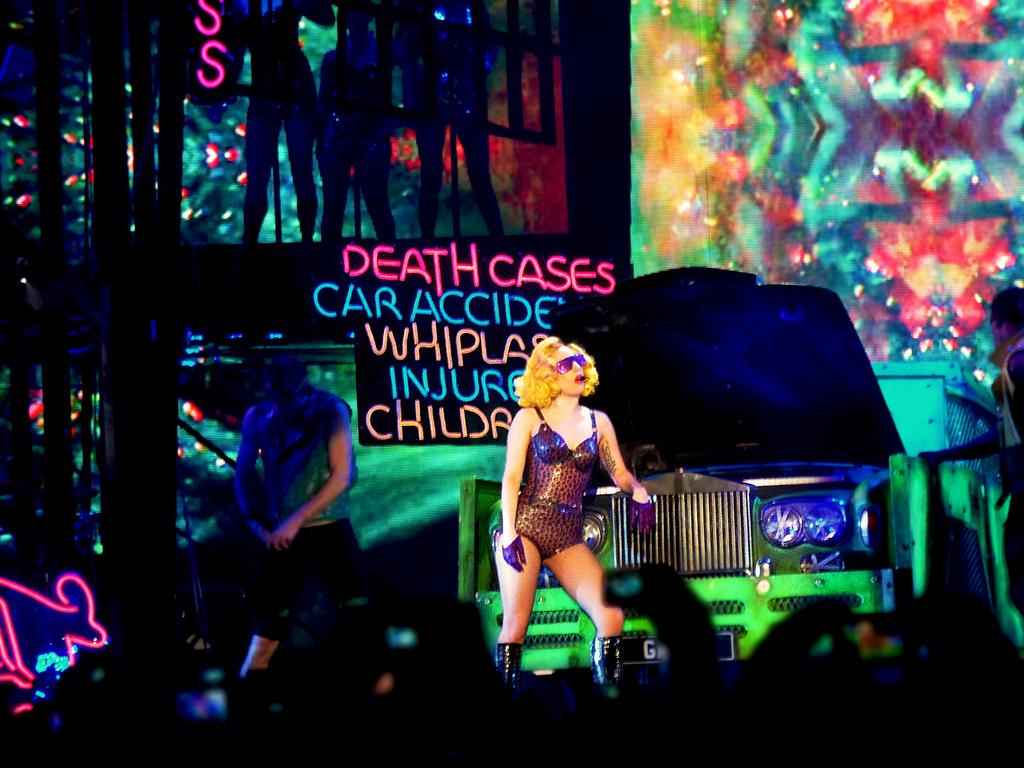Who is present in the image? There are people in the image. What are some of the people doing in the image? Some people are holding cameras in their hands. What else can be seen in the image besides people and cameras? There is a car and banners in the image. Are there any masks visible on the people in the image? There is no mention of masks in the provided facts, so we cannot determine if any masks are visible in the image. 